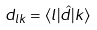<formula> <loc_0><loc_0><loc_500><loc_500>d _ { l k } = \langle l | \hat { d } | k \rangle</formula> 